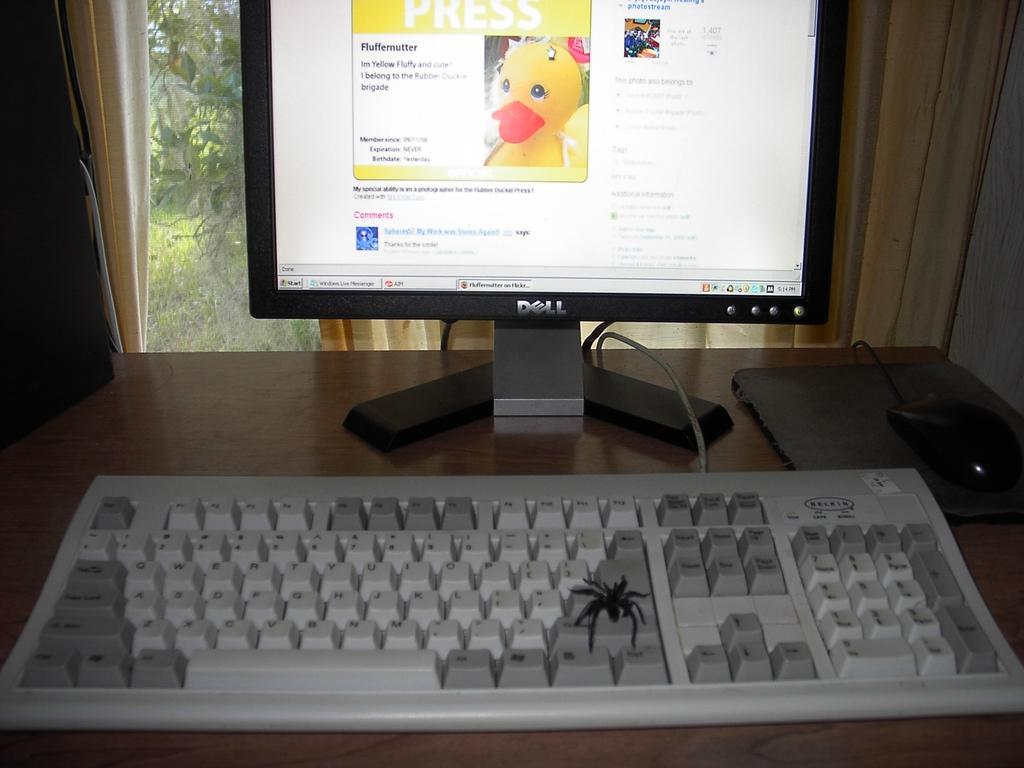What electronic device is located on the table in the image? There is a keyboard and a mouse on the table in the image. What is the primary output device for the computer setup? There is a monitor on the table, which is the primary output device. What is the natural element visible through the window? Plants are visible through the window in the image. What type of window treatment is present in the image? There is a curtain associated with the window. What type of route can be seen on the map in the image? There is no map present in the image, so it is not possible to determine the type of route. --- 